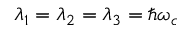Convert formula to latex. <formula><loc_0><loc_0><loc_500><loc_500>\lambda _ { 1 } = \lambda _ { 2 } = \lambda _ { 3 } = \hbar { \omega } _ { c }</formula> 